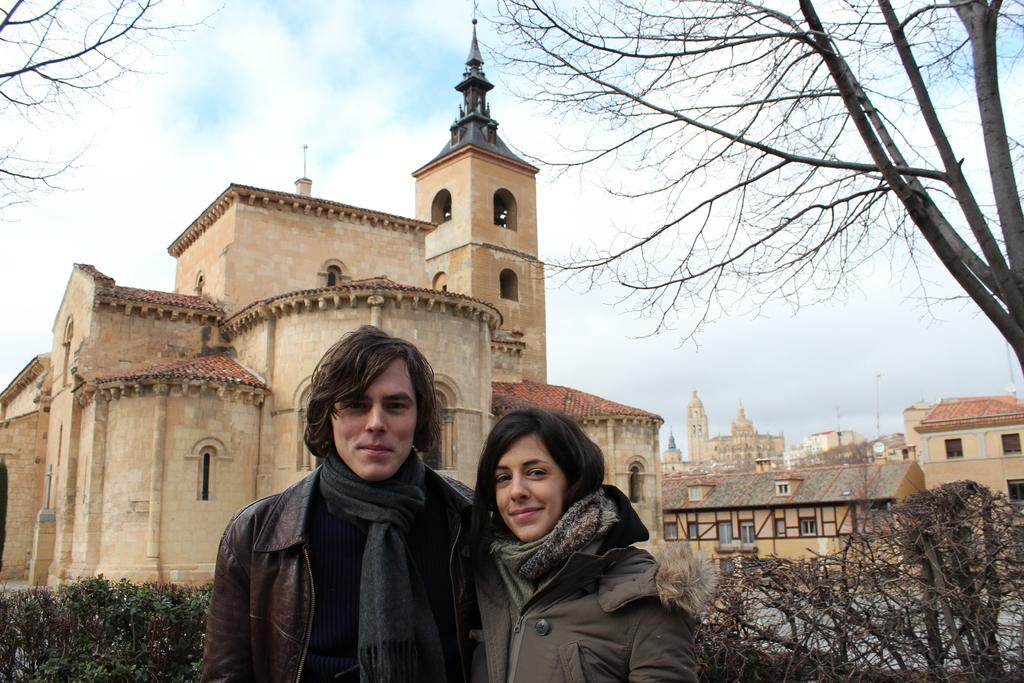How many people are in the image? There are 2 people standing in the image. What are the people wearing? The people are wearing coats. What can be seen in the image besides the people? There are plants, buildings, and a tree visible in the image. What is visible at the top of the image? The sky is visible at the top of the image. What type of station does the dad work at in the image? There is no dad or station present in the image. How many women are in the image? The image does not specify the gender of the people, so we cannot determine if there are any women present. 